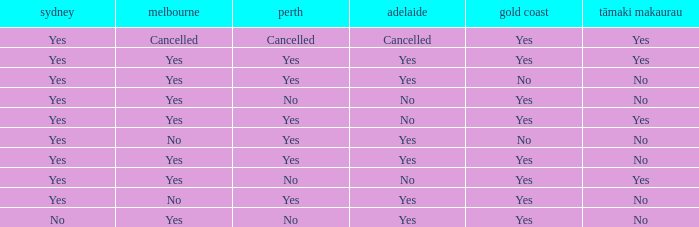What is the sydney that has adelaide, gold coast, melbourne, and auckland are all yes? Yes. Could you help me parse every detail presented in this table? {'header': ['sydney', 'melbourne', 'perth', 'adelaide', 'gold coast', 'tāmaki makaurau'], 'rows': [['Yes', 'Cancelled', 'Cancelled', 'Cancelled', 'Yes', 'Yes'], ['Yes', 'Yes', 'Yes', 'Yes', 'Yes', 'Yes'], ['Yes', 'Yes', 'Yes', 'Yes', 'No', 'No'], ['Yes', 'Yes', 'No', 'No', 'Yes', 'No'], ['Yes', 'Yes', 'Yes', 'No', 'Yes', 'Yes'], ['Yes', 'No', 'Yes', 'Yes', 'No', 'No'], ['Yes', 'Yes', 'Yes', 'Yes', 'Yes', 'No'], ['Yes', 'Yes', 'No', 'No', 'Yes', 'Yes'], ['Yes', 'No', 'Yes', 'Yes', 'Yes', 'No'], ['No', 'Yes', 'No', 'Yes', 'Yes', 'No']]} 